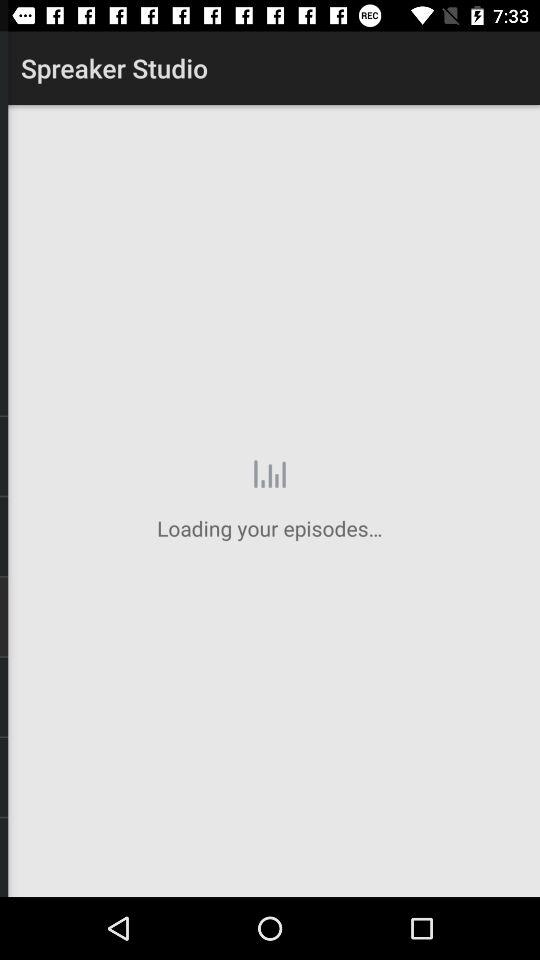What is the user's name? The user's name is John. 